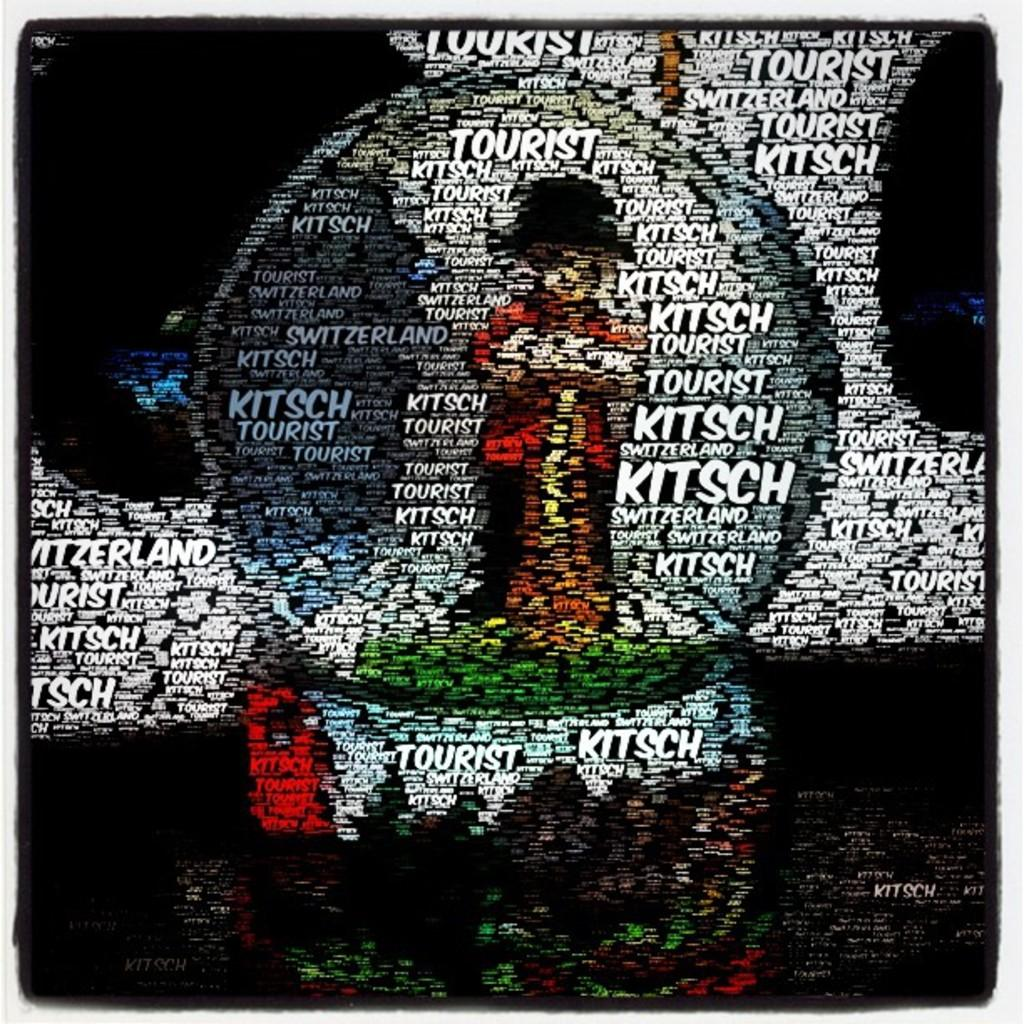<image>
Write a terse but informative summary of the picture. a piece of art that says tourist and kitsch as well as Switzerland printed all over it. 